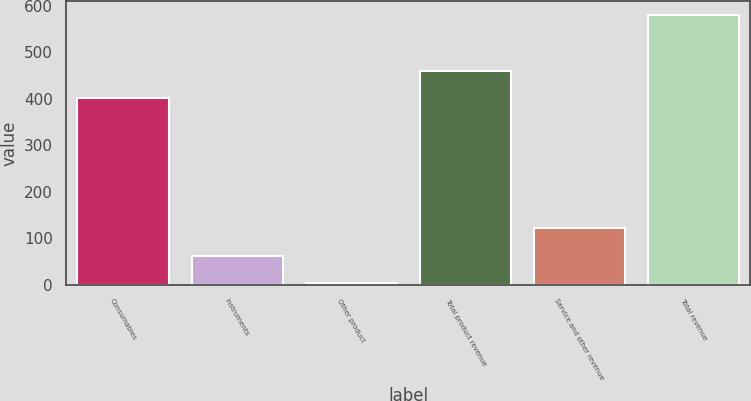Convert chart. <chart><loc_0><loc_0><loc_500><loc_500><bar_chart><fcel>Consumables<fcel>Instruments<fcel>Other product<fcel>Total product revenue<fcel>Service and other revenue<fcel>Total revenue<nl><fcel>403<fcel>60.8<fcel>3<fcel>460.8<fcel>121<fcel>581<nl></chart> 